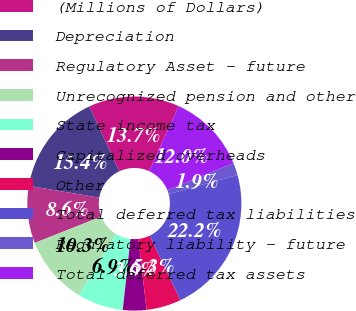<chart> <loc_0><loc_0><loc_500><loc_500><pie_chart><fcel>(Millions of Dollars)<fcel>Depreciation<fcel>Regulatory Asset - future<fcel>Unrecognized pension and other<fcel>State income tax<fcel>Capitalized overheads<fcel>Other<fcel>Total deferred tax liabilities<fcel>Regulatory liability - future<fcel>Total deferred tax assets<nl><fcel>13.73%<fcel>15.43%<fcel>8.64%<fcel>10.34%<fcel>6.94%<fcel>3.55%<fcel>5.25%<fcel>22.22%<fcel>1.85%<fcel>12.04%<nl></chart> 